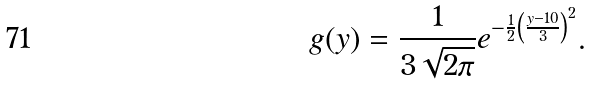<formula> <loc_0><loc_0><loc_500><loc_500>g ( y ) = \frac { 1 } { 3 \sqrt { 2 \pi } } e ^ { - \frac { 1 } { 2 } \left ( \frac { y - 1 0 } { 3 } \right ) ^ { 2 } } .</formula> 